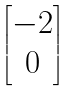Convert formula to latex. <formula><loc_0><loc_0><loc_500><loc_500>\begin{bmatrix} - 2 \\ 0 \end{bmatrix}</formula> 